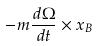<formula> <loc_0><loc_0><loc_500><loc_500>- m \frac { d \Omega } { d t } \times x _ { B }</formula> 